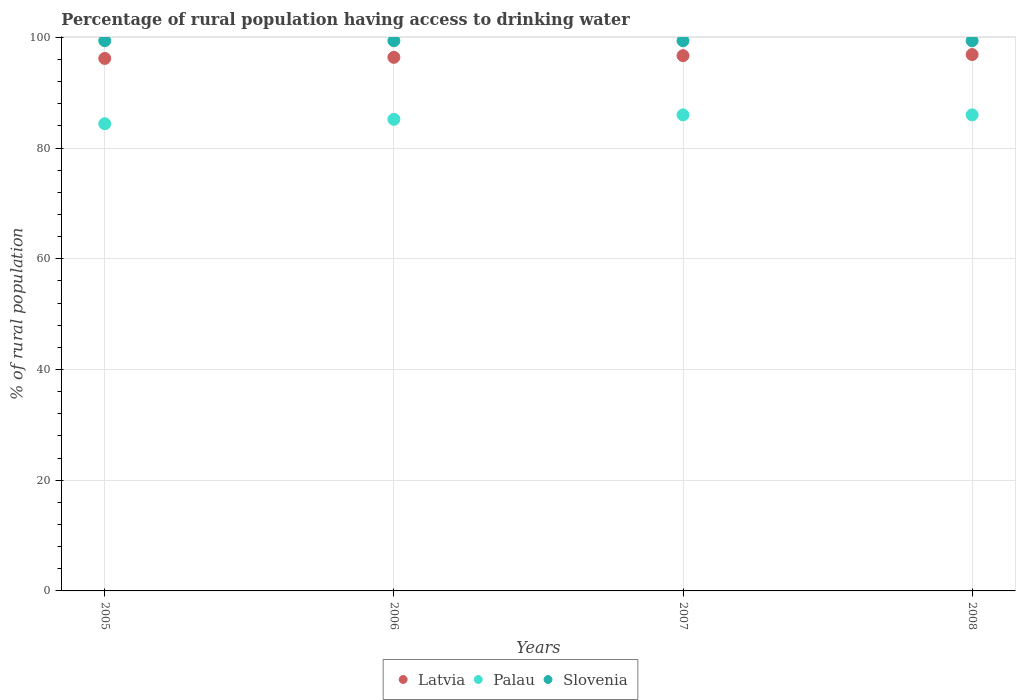Is the number of dotlines equal to the number of legend labels?
Make the answer very short. Yes. What is the percentage of rural population having access to drinking water in Slovenia in 2006?
Provide a succinct answer. 99.4. Across all years, what is the maximum percentage of rural population having access to drinking water in Palau?
Give a very brief answer. 86. Across all years, what is the minimum percentage of rural population having access to drinking water in Latvia?
Offer a very short reply. 96.2. In which year was the percentage of rural population having access to drinking water in Latvia maximum?
Your response must be concise. 2008. In which year was the percentage of rural population having access to drinking water in Latvia minimum?
Your response must be concise. 2005. What is the total percentage of rural population having access to drinking water in Palau in the graph?
Your response must be concise. 341.6. What is the difference between the percentage of rural population having access to drinking water in Latvia in 2006 and that in 2008?
Offer a very short reply. -0.5. What is the difference between the percentage of rural population having access to drinking water in Palau in 2006 and the percentage of rural population having access to drinking water in Slovenia in 2005?
Keep it short and to the point. -14.2. What is the average percentage of rural population having access to drinking water in Latvia per year?
Provide a short and direct response. 96.55. In the year 2007, what is the difference between the percentage of rural population having access to drinking water in Slovenia and percentage of rural population having access to drinking water in Latvia?
Your answer should be compact. 2.7. In how many years, is the percentage of rural population having access to drinking water in Latvia greater than the average percentage of rural population having access to drinking water in Latvia taken over all years?
Your answer should be compact. 2. Does the percentage of rural population having access to drinking water in Slovenia monotonically increase over the years?
Your answer should be very brief. No. Is the percentage of rural population having access to drinking water in Slovenia strictly greater than the percentage of rural population having access to drinking water in Latvia over the years?
Ensure brevity in your answer.  Yes. Is the percentage of rural population having access to drinking water in Latvia strictly less than the percentage of rural population having access to drinking water in Slovenia over the years?
Offer a terse response. Yes. How many dotlines are there?
Your answer should be compact. 3. Are the values on the major ticks of Y-axis written in scientific E-notation?
Your answer should be very brief. No. How are the legend labels stacked?
Your answer should be compact. Horizontal. What is the title of the graph?
Give a very brief answer. Percentage of rural population having access to drinking water. Does "Greece" appear as one of the legend labels in the graph?
Provide a succinct answer. No. What is the label or title of the X-axis?
Make the answer very short. Years. What is the label or title of the Y-axis?
Ensure brevity in your answer.  % of rural population. What is the % of rural population in Latvia in 2005?
Make the answer very short. 96.2. What is the % of rural population in Palau in 2005?
Your answer should be very brief. 84.4. What is the % of rural population of Slovenia in 2005?
Offer a very short reply. 99.4. What is the % of rural population in Latvia in 2006?
Provide a succinct answer. 96.4. What is the % of rural population of Palau in 2006?
Make the answer very short. 85.2. What is the % of rural population in Slovenia in 2006?
Your answer should be very brief. 99.4. What is the % of rural population in Latvia in 2007?
Provide a short and direct response. 96.7. What is the % of rural population in Palau in 2007?
Your response must be concise. 86. What is the % of rural population in Slovenia in 2007?
Keep it short and to the point. 99.4. What is the % of rural population in Latvia in 2008?
Give a very brief answer. 96.9. What is the % of rural population in Slovenia in 2008?
Provide a short and direct response. 99.4. Across all years, what is the maximum % of rural population of Latvia?
Ensure brevity in your answer.  96.9. Across all years, what is the maximum % of rural population in Palau?
Keep it short and to the point. 86. Across all years, what is the maximum % of rural population in Slovenia?
Give a very brief answer. 99.4. Across all years, what is the minimum % of rural population in Latvia?
Offer a very short reply. 96.2. Across all years, what is the minimum % of rural population of Palau?
Your answer should be compact. 84.4. Across all years, what is the minimum % of rural population of Slovenia?
Your answer should be compact. 99.4. What is the total % of rural population of Latvia in the graph?
Provide a short and direct response. 386.2. What is the total % of rural population in Palau in the graph?
Your response must be concise. 341.6. What is the total % of rural population of Slovenia in the graph?
Offer a very short reply. 397.6. What is the difference between the % of rural population in Latvia in 2005 and that in 2006?
Offer a terse response. -0.2. What is the difference between the % of rural population of Slovenia in 2005 and that in 2006?
Make the answer very short. 0. What is the difference between the % of rural population of Latvia in 2005 and that in 2007?
Provide a succinct answer. -0.5. What is the difference between the % of rural population in Palau in 2005 and that in 2008?
Give a very brief answer. -1.6. What is the difference between the % of rural population in Slovenia in 2005 and that in 2008?
Your response must be concise. 0. What is the difference between the % of rural population in Latvia in 2006 and that in 2007?
Your answer should be compact. -0.3. What is the difference between the % of rural population of Palau in 2006 and that in 2007?
Provide a succinct answer. -0.8. What is the difference between the % of rural population in Slovenia in 2006 and that in 2007?
Your answer should be very brief. 0. What is the difference between the % of rural population of Palau in 2006 and that in 2008?
Offer a terse response. -0.8. What is the difference between the % of rural population in Latvia in 2007 and that in 2008?
Offer a terse response. -0.2. What is the difference between the % of rural population of Latvia in 2005 and the % of rural population of Palau in 2006?
Offer a very short reply. 11. What is the difference between the % of rural population in Latvia in 2005 and the % of rural population in Palau in 2008?
Your response must be concise. 10.2. What is the difference between the % of rural population of Latvia in 2005 and the % of rural population of Slovenia in 2008?
Provide a short and direct response. -3.2. What is the difference between the % of rural population in Palau in 2005 and the % of rural population in Slovenia in 2008?
Give a very brief answer. -15. What is the difference between the % of rural population of Latvia in 2006 and the % of rural population of Slovenia in 2007?
Your answer should be very brief. -3. What is the difference between the % of rural population in Latvia in 2006 and the % of rural population in Palau in 2008?
Offer a very short reply. 10.4. What is the difference between the % of rural population in Palau in 2006 and the % of rural population in Slovenia in 2008?
Make the answer very short. -14.2. What is the difference between the % of rural population in Latvia in 2007 and the % of rural population in Palau in 2008?
Ensure brevity in your answer.  10.7. What is the difference between the % of rural population of Palau in 2007 and the % of rural population of Slovenia in 2008?
Your answer should be very brief. -13.4. What is the average % of rural population of Latvia per year?
Provide a succinct answer. 96.55. What is the average % of rural population in Palau per year?
Your response must be concise. 85.4. What is the average % of rural population of Slovenia per year?
Ensure brevity in your answer.  99.4. In the year 2006, what is the difference between the % of rural population of Latvia and % of rural population of Slovenia?
Give a very brief answer. -3. In the year 2006, what is the difference between the % of rural population in Palau and % of rural population in Slovenia?
Keep it short and to the point. -14.2. In the year 2007, what is the difference between the % of rural population in Palau and % of rural population in Slovenia?
Provide a short and direct response. -13.4. In the year 2008, what is the difference between the % of rural population of Latvia and % of rural population of Palau?
Your answer should be compact. 10.9. In the year 2008, what is the difference between the % of rural population in Palau and % of rural population in Slovenia?
Keep it short and to the point. -13.4. What is the ratio of the % of rural population of Palau in 2005 to that in 2006?
Keep it short and to the point. 0.99. What is the ratio of the % of rural population of Latvia in 2005 to that in 2007?
Provide a succinct answer. 0.99. What is the ratio of the % of rural population of Palau in 2005 to that in 2007?
Ensure brevity in your answer.  0.98. What is the ratio of the % of rural population of Slovenia in 2005 to that in 2007?
Offer a very short reply. 1. What is the ratio of the % of rural population in Latvia in 2005 to that in 2008?
Provide a short and direct response. 0.99. What is the ratio of the % of rural population in Palau in 2005 to that in 2008?
Make the answer very short. 0.98. What is the ratio of the % of rural population in Slovenia in 2006 to that in 2008?
Make the answer very short. 1. What is the ratio of the % of rural population in Latvia in 2007 to that in 2008?
Ensure brevity in your answer.  1. What is the ratio of the % of rural population in Palau in 2007 to that in 2008?
Offer a very short reply. 1. What is the difference between the highest and the lowest % of rural population in Latvia?
Give a very brief answer. 0.7. 